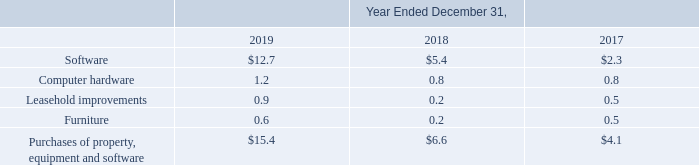Cash used in investing activities
Detail of the cash used in investing activities is included below for each year (dollars in millions).
2019 vs. 2018. The $8.8 million higher spend on investing activities during 2019 compared to 2018 was primarily related to an increase in capitalized costs associated with various internally-developed software projects, such as mobile application development and transaction processing, an increase in hardware costs primarily associated with our growing infrastructure needs and an increase in leasehold improvements associated with security build outs of expanded office space.
2018 vs. 2017. We had net cash used in investing activities of $6.6 million during 2018 compared to $4.1 million during 2017. The higher spend in 2018 was primarily related to an increase in software expenditures, most of which were capitalized costs related to internally-developed software, which consisted primarily of merchant experience enhancements and mobile application development. This activity was partially offset by lower infrastructure expenditures in 2018 compared to 2017, as we did not have any material changes to our leased premises during 2018.
Which years does the table provide information for the cash used in investing activities? 2019, 2018, 2017. What was the cash used in Software in 2019?
Answer scale should be: million. 12.7. What was the cash used in Computer Hardware in 2017?
Answer scale should be: million. 0.8. Which years did cash used in Furniture exceed $0.3 million? (2019:0.6),(2017:0.5)
Answer: 2019, 2017. What was the change in the cash used in Leasehold Improvements between 2017 and 2019?
Answer scale should be: million. 0.9-0.5
Answer: 0.4. What was the percentage change in the Purchases of property, equipment and software between 2018 and 2019?
Answer scale should be: percent. (15.4-6.6)/6.6
Answer: 133.33. 